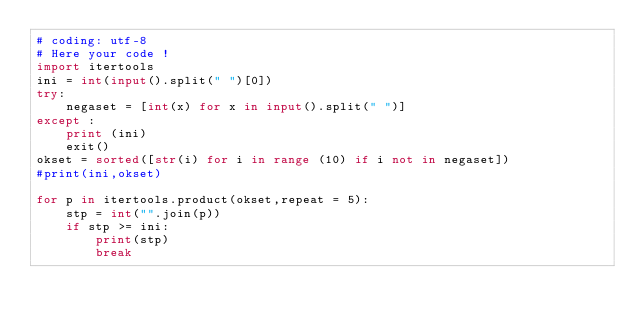Convert code to text. <code><loc_0><loc_0><loc_500><loc_500><_Python_># coding: utf-8
# Here your code !
import itertools
ini = int(input().split(" ")[0])
try:
    negaset = [int(x) for x in input().split(" ")]
except :
    print (ini)
    exit()
okset = sorted([str(i) for i in range (10) if i not in negaset]) 
#print(ini,okset)

for p in itertools.product(okset,repeat = 5):
    stp = int("".join(p))
    if stp >= ini:
        print(stp)
        break</code> 